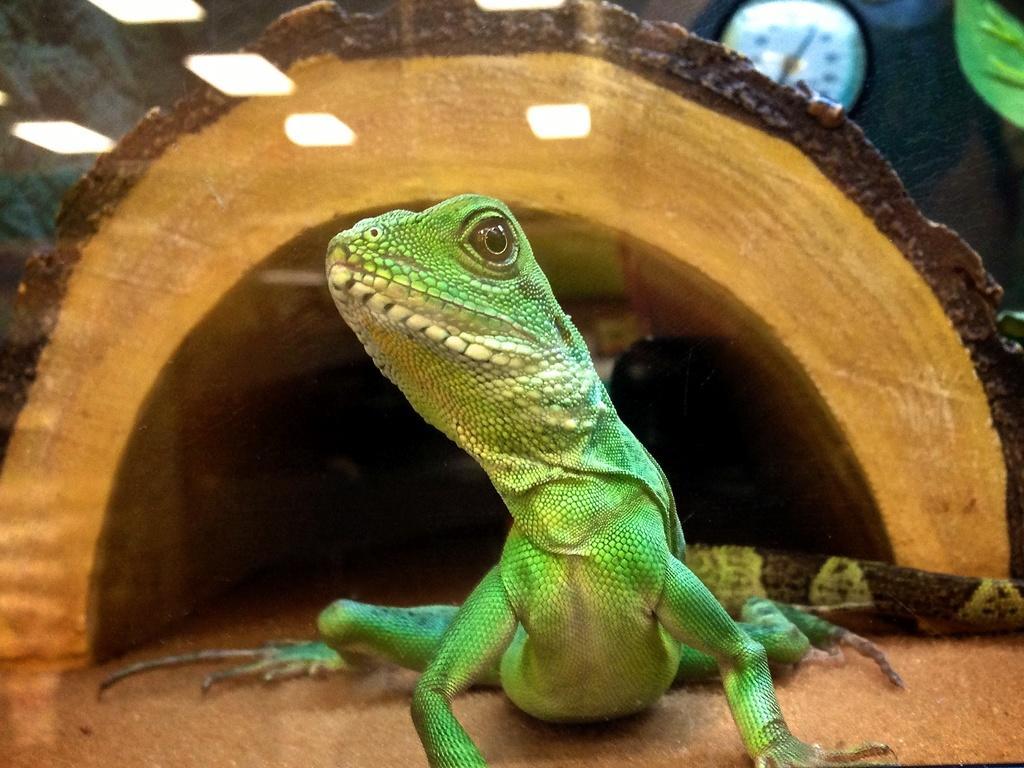In one or two sentences, can you explain what this image depicts? We can see reptile and cage. In the background we can see clock. 